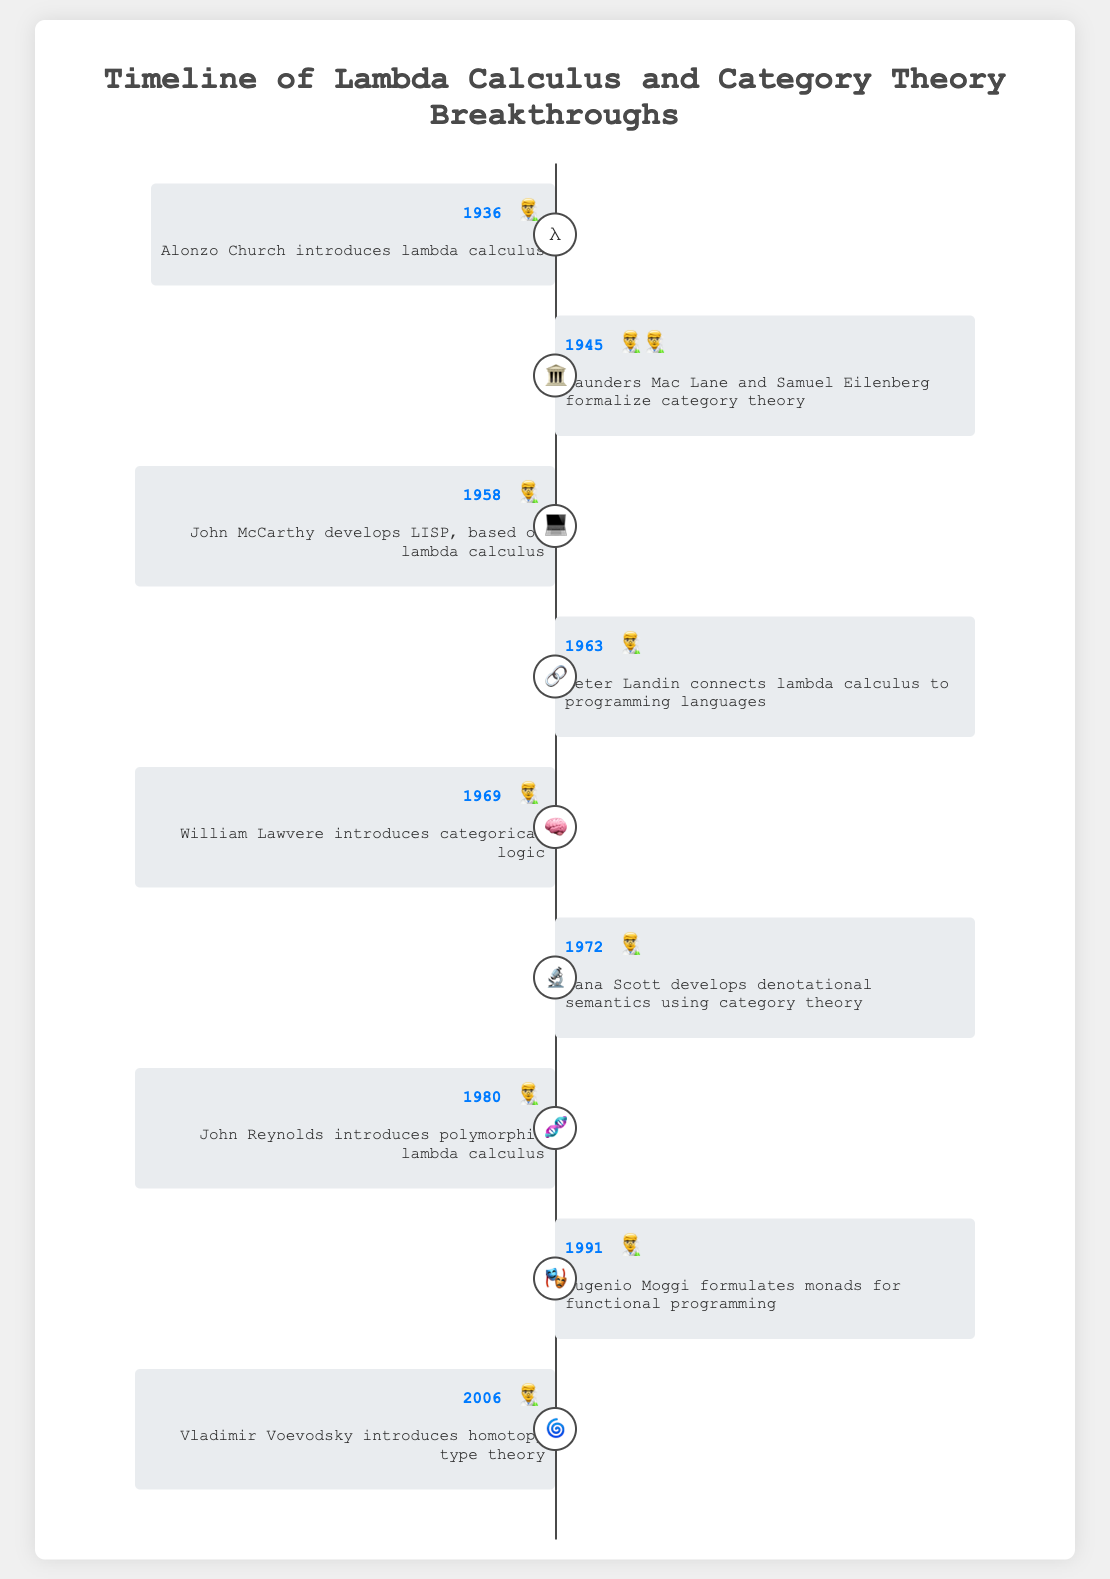What is the title of the timeline? The title is at the top of the timeline and is written in a larger font size than the other text.
Answer: Timeline of Lambda Calculus and Category Theory Breakthroughs Which event took place in 2006? Locate the event with the year 2006 and read the corresponding description.
Answer: Vladimir Voevodsky introduces homotopy type theory Who developed denotational semantics using category theory and in what year? Find the event that mentions denotational semantics and note who and what year it was.
Answer: Dana Scott in 1972 How many years after introducing lambda calculus was categorical logic introduced? Subtract the year lambda calculus was introduced from the year categorical logic was introduced (1969 - 1936).
Answer: 33 years Which event related to lambda calculus occurred earliest? Identify the earliest year associated with a lambda calculus event.
Answer: Alonzo Church introduces lambda calculus in 1936 Is the event of John McCarthy developing LISP before or after Dana Scott’s development of denotational semantics? Compare the year John McCarthy developed LISP with the year Dana Scott developed denotational semantics.
Answer: Before Who are the two scientists that formalized category theory? Look for the event related to formalizing category theory and identify the scientists mentioned.
Answer: Saunders Mac Lane and Samuel Eilenberg What is the emoji representation for the event in 1991? Find the event for the year 1991 and check the emoji used for representation.
Answer: 🎭 How many events are associated with significant breakthroughs in lambda calculus within the timeline? Count the number of events specifically mentioning lambda calculus.
Answer: 5 events Who introduced polymorphic lambda calculus and in what year? Identify the event mentioning polymorphic lambda calculus and note the person and the year.
Answer: John Reynolds in 1980 